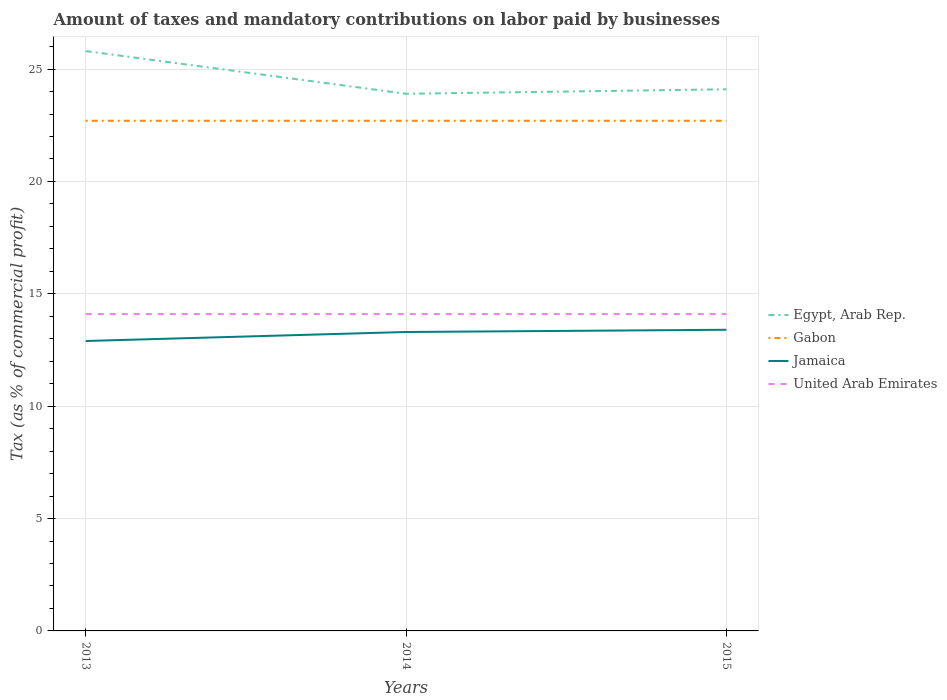How many different coloured lines are there?
Your response must be concise. 4. Does the line corresponding to Egypt, Arab Rep. intersect with the line corresponding to United Arab Emirates?
Offer a very short reply. No. Across all years, what is the maximum percentage of taxes paid by businesses in Egypt, Arab Rep.?
Keep it short and to the point. 23.9. What is the total percentage of taxes paid by businesses in Gabon in the graph?
Keep it short and to the point. 0. How many lines are there?
Give a very brief answer. 4. Are the values on the major ticks of Y-axis written in scientific E-notation?
Your answer should be compact. No. Does the graph contain grids?
Offer a very short reply. Yes. How many legend labels are there?
Your answer should be compact. 4. How are the legend labels stacked?
Ensure brevity in your answer.  Vertical. What is the title of the graph?
Ensure brevity in your answer.  Amount of taxes and mandatory contributions on labor paid by businesses. What is the label or title of the X-axis?
Make the answer very short. Years. What is the label or title of the Y-axis?
Give a very brief answer. Tax (as % of commercial profit). What is the Tax (as % of commercial profit) in Egypt, Arab Rep. in 2013?
Make the answer very short. 25.8. What is the Tax (as % of commercial profit) in Gabon in 2013?
Offer a very short reply. 22.7. What is the Tax (as % of commercial profit) of Egypt, Arab Rep. in 2014?
Provide a short and direct response. 23.9. What is the Tax (as % of commercial profit) in Gabon in 2014?
Your answer should be compact. 22.7. What is the Tax (as % of commercial profit) in Jamaica in 2014?
Provide a short and direct response. 13.3. What is the Tax (as % of commercial profit) of United Arab Emirates in 2014?
Provide a succinct answer. 14.1. What is the Tax (as % of commercial profit) in Egypt, Arab Rep. in 2015?
Provide a short and direct response. 24.1. What is the Tax (as % of commercial profit) in Gabon in 2015?
Your answer should be very brief. 22.7. What is the Tax (as % of commercial profit) in Jamaica in 2015?
Your answer should be very brief. 13.4. What is the Tax (as % of commercial profit) of United Arab Emirates in 2015?
Your answer should be compact. 14.1. Across all years, what is the maximum Tax (as % of commercial profit) of Egypt, Arab Rep.?
Your response must be concise. 25.8. Across all years, what is the maximum Tax (as % of commercial profit) in Gabon?
Provide a short and direct response. 22.7. Across all years, what is the maximum Tax (as % of commercial profit) of United Arab Emirates?
Your response must be concise. 14.1. Across all years, what is the minimum Tax (as % of commercial profit) in Egypt, Arab Rep.?
Make the answer very short. 23.9. Across all years, what is the minimum Tax (as % of commercial profit) in Gabon?
Provide a short and direct response. 22.7. What is the total Tax (as % of commercial profit) in Egypt, Arab Rep. in the graph?
Ensure brevity in your answer.  73.8. What is the total Tax (as % of commercial profit) in Gabon in the graph?
Provide a short and direct response. 68.1. What is the total Tax (as % of commercial profit) of Jamaica in the graph?
Give a very brief answer. 39.6. What is the total Tax (as % of commercial profit) of United Arab Emirates in the graph?
Offer a terse response. 42.3. What is the difference between the Tax (as % of commercial profit) in Egypt, Arab Rep. in 2013 and that in 2014?
Provide a short and direct response. 1.9. What is the difference between the Tax (as % of commercial profit) of Gabon in 2013 and that in 2014?
Give a very brief answer. 0. What is the difference between the Tax (as % of commercial profit) of Jamaica in 2013 and that in 2014?
Your response must be concise. -0.4. What is the difference between the Tax (as % of commercial profit) in United Arab Emirates in 2014 and that in 2015?
Your answer should be very brief. 0. What is the difference between the Tax (as % of commercial profit) in Egypt, Arab Rep. in 2013 and the Tax (as % of commercial profit) in Gabon in 2014?
Give a very brief answer. 3.1. What is the difference between the Tax (as % of commercial profit) of Egypt, Arab Rep. in 2013 and the Tax (as % of commercial profit) of Jamaica in 2014?
Keep it short and to the point. 12.5. What is the difference between the Tax (as % of commercial profit) of Egypt, Arab Rep. in 2013 and the Tax (as % of commercial profit) of United Arab Emirates in 2014?
Your answer should be compact. 11.7. What is the difference between the Tax (as % of commercial profit) in Gabon in 2013 and the Tax (as % of commercial profit) in Jamaica in 2014?
Your answer should be very brief. 9.4. What is the difference between the Tax (as % of commercial profit) in Jamaica in 2013 and the Tax (as % of commercial profit) in United Arab Emirates in 2014?
Give a very brief answer. -1.2. What is the difference between the Tax (as % of commercial profit) in Egypt, Arab Rep. in 2013 and the Tax (as % of commercial profit) in Gabon in 2015?
Give a very brief answer. 3.1. What is the difference between the Tax (as % of commercial profit) in Gabon in 2013 and the Tax (as % of commercial profit) in Jamaica in 2015?
Your answer should be compact. 9.3. What is the difference between the Tax (as % of commercial profit) of Gabon in 2013 and the Tax (as % of commercial profit) of United Arab Emirates in 2015?
Keep it short and to the point. 8.6. What is the difference between the Tax (as % of commercial profit) in Egypt, Arab Rep. in 2014 and the Tax (as % of commercial profit) in Jamaica in 2015?
Provide a succinct answer. 10.5. What is the difference between the Tax (as % of commercial profit) of Egypt, Arab Rep. in 2014 and the Tax (as % of commercial profit) of United Arab Emirates in 2015?
Give a very brief answer. 9.8. What is the average Tax (as % of commercial profit) in Egypt, Arab Rep. per year?
Your answer should be compact. 24.6. What is the average Tax (as % of commercial profit) in Gabon per year?
Ensure brevity in your answer.  22.7. What is the average Tax (as % of commercial profit) of Jamaica per year?
Provide a succinct answer. 13.2. What is the average Tax (as % of commercial profit) of United Arab Emirates per year?
Your answer should be compact. 14.1. In the year 2013, what is the difference between the Tax (as % of commercial profit) in Egypt, Arab Rep. and Tax (as % of commercial profit) in Gabon?
Your answer should be compact. 3.1. In the year 2013, what is the difference between the Tax (as % of commercial profit) in Egypt, Arab Rep. and Tax (as % of commercial profit) in Jamaica?
Offer a terse response. 12.9. In the year 2013, what is the difference between the Tax (as % of commercial profit) of Egypt, Arab Rep. and Tax (as % of commercial profit) of United Arab Emirates?
Your answer should be very brief. 11.7. In the year 2013, what is the difference between the Tax (as % of commercial profit) of Gabon and Tax (as % of commercial profit) of Jamaica?
Your response must be concise. 9.8. In the year 2013, what is the difference between the Tax (as % of commercial profit) in Gabon and Tax (as % of commercial profit) in United Arab Emirates?
Keep it short and to the point. 8.6. In the year 2013, what is the difference between the Tax (as % of commercial profit) of Jamaica and Tax (as % of commercial profit) of United Arab Emirates?
Your response must be concise. -1.2. In the year 2014, what is the difference between the Tax (as % of commercial profit) in Egypt, Arab Rep. and Tax (as % of commercial profit) in Jamaica?
Give a very brief answer. 10.6. In the year 2015, what is the difference between the Tax (as % of commercial profit) in Egypt, Arab Rep. and Tax (as % of commercial profit) in United Arab Emirates?
Make the answer very short. 10. In the year 2015, what is the difference between the Tax (as % of commercial profit) of Gabon and Tax (as % of commercial profit) of Jamaica?
Offer a very short reply. 9.3. In the year 2015, what is the difference between the Tax (as % of commercial profit) of Jamaica and Tax (as % of commercial profit) of United Arab Emirates?
Ensure brevity in your answer.  -0.7. What is the ratio of the Tax (as % of commercial profit) of Egypt, Arab Rep. in 2013 to that in 2014?
Provide a succinct answer. 1.08. What is the ratio of the Tax (as % of commercial profit) in Gabon in 2013 to that in 2014?
Keep it short and to the point. 1. What is the ratio of the Tax (as % of commercial profit) in Jamaica in 2013 to that in 2014?
Your answer should be compact. 0.97. What is the ratio of the Tax (as % of commercial profit) in Egypt, Arab Rep. in 2013 to that in 2015?
Your answer should be very brief. 1.07. What is the ratio of the Tax (as % of commercial profit) of Jamaica in 2013 to that in 2015?
Keep it short and to the point. 0.96. What is the ratio of the Tax (as % of commercial profit) of United Arab Emirates in 2013 to that in 2015?
Provide a succinct answer. 1. What is the ratio of the Tax (as % of commercial profit) of Egypt, Arab Rep. in 2014 to that in 2015?
Your response must be concise. 0.99. What is the ratio of the Tax (as % of commercial profit) in Gabon in 2014 to that in 2015?
Ensure brevity in your answer.  1. What is the ratio of the Tax (as % of commercial profit) of Jamaica in 2014 to that in 2015?
Make the answer very short. 0.99. What is the ratio of the Tax (as % of commercial profit) of United Arab Emirates in 2014 to that in 2015?
Your answer should be very brief. 1. What is the difference between the highest and the lowest Tax (as % of commercial profit) in Egypt, Arab Rep.?
Your answer should be compact. 1.9. What is the difference between the highest and the lowest Tax (as % of commercial profit) of United Arab Emirates?
Offer a terse response. 0. 